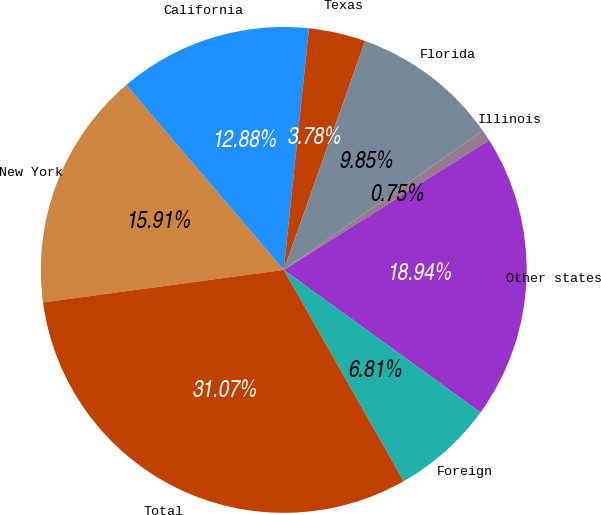Convert chart. <chart><loc_0><loc_0><loc_500><loc_500><pie_chart><fcel>New York<fcel>California<fcel>Texas<fcel>Florida<fcel>Illinois<fcel>Other states<fcel>Foreign<fcel>Total<nl><fcel>15.91%<fcel>12.88%<fcel>3.78%<fcel>9.85%<fcel>0.75%<fcel>18.94%<fcel>6.81%<fcel>31.07%<nl></chart> 